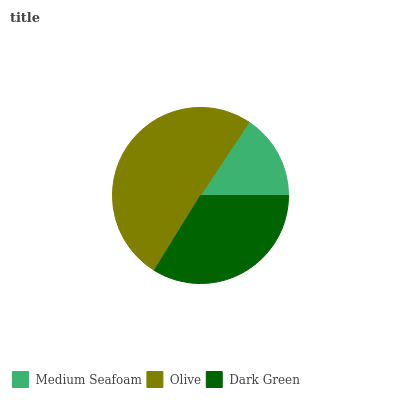Is Medium Seafoam the minimum?
Answer yes or no. Yes. Is Olive the maximum?
Answer yes or no. Yes. Is Dark Green the minimum?
Answer yes or no. No. Is Dark Green the maximum?
Answer yes or no. No. Is Olive greater than Dark Green?
Answer yes or no. Yes. Is Dark Green less than Olive?
Answer yes or no. Yes. Is Dark Green greater than Olive?
Answer yes or no. No. Is Olive less than Dark Green?
Answer yes or no. No. Is Dark Green the high median?
Answer yes or no. Yes. Is Dark Green the low median?
Answer yes or no. Yes. Is Medium Seafoam the high median?
Answer yes or no. No. Is Olive the low median?
Answer yes or no. No. 